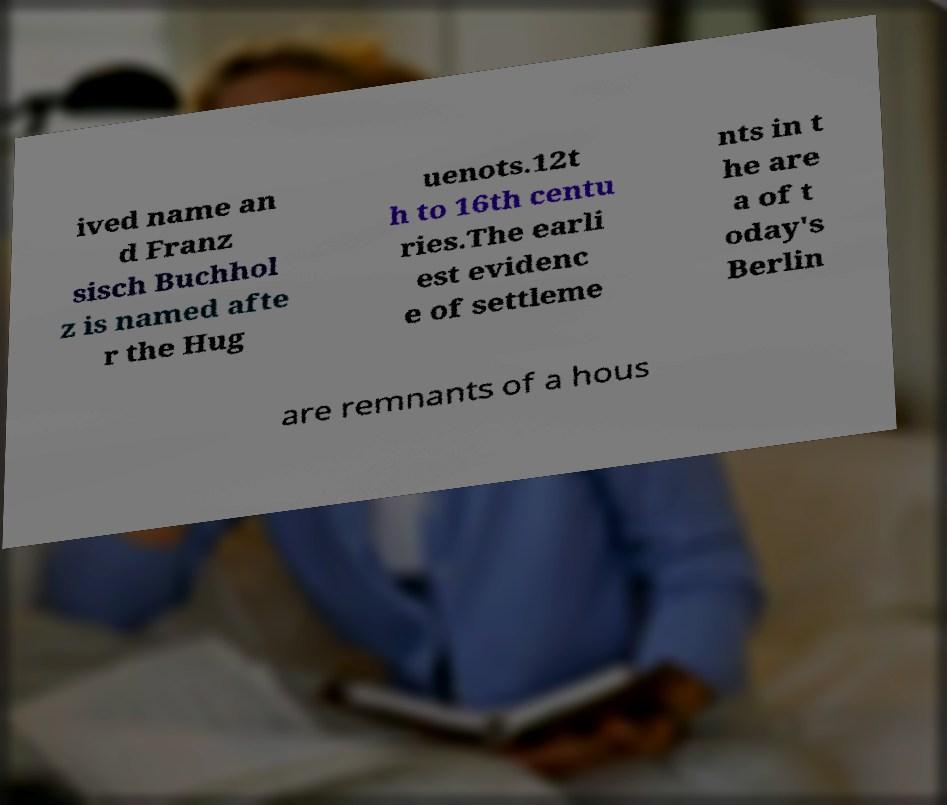I need the written content from this picture converted into text. Can you do that? ived name an d Franz sisch Buchhol z is named afte r the Hug uenots.12t h to 16th centu ries.The earli est evidenc e of settleme nts in t he are a of t oday's Berlin are remnants of a hous 